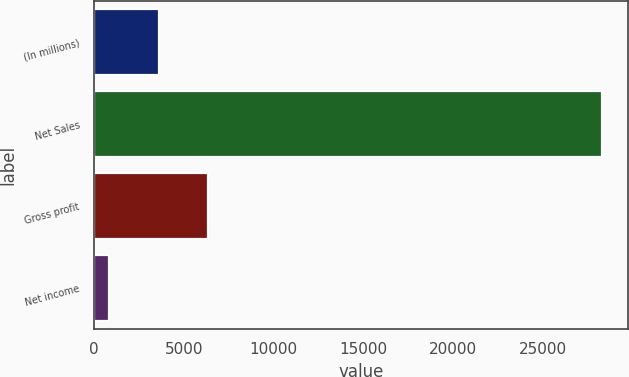Convert chart. <chart><loc_0><loc_0><loc_500><loc_500><bar_chart><fcel>(In millions)<fcel>Net Sales<fcel>Gross profit<fcel>Net income<nl><fcel>3600.9<fcel>28314<fcel>6346.8<fcel>855<nl></chart> 